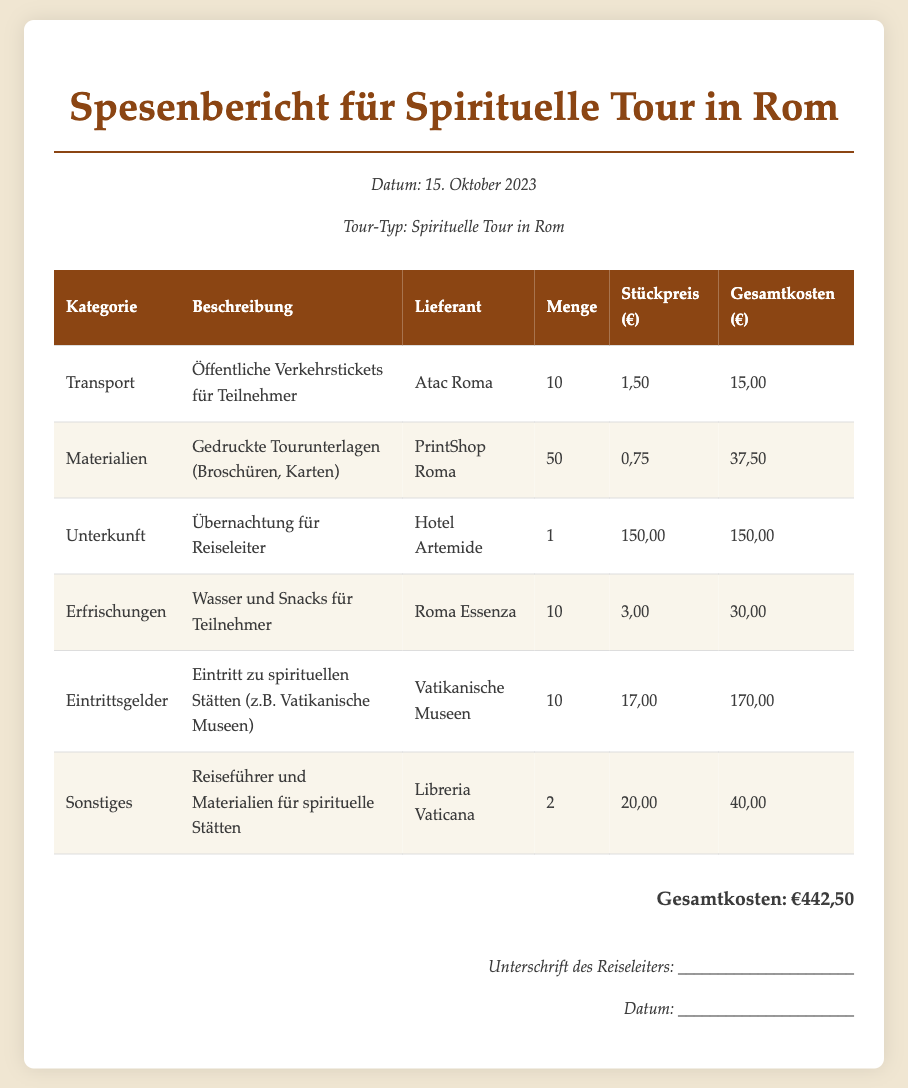Was ist das Datum des Spesenberichts? Das Datum des Spesenberichts ist im Bericht selbst ausgewiesen.
Answer: 15. Oktober 2023 Wie hoch sind die Gesamtkosten? Die Gesamtkosten sind am Ende des Berichts aufgeführt.
Answer: €442,50 Wer ist der Lieferant für die öffentlichen Verkehrstickets? Der Lieferant für die öffentlichen Verkehrstickets ist im jeweiligen Abschnitt angegeben.
Answer: Atac Roma Wie viele gedruckte Tourunterlagen wurden bestellt? Die Menge der gedruckten Tourunterlagen ist im entsprechenden Eintrag zu finden.
Answer: 50 Was kostet das Eintrittsgeld zu den spirituellen Stätten pro Person? Der Stückpreis für das Eintrittsgeld ist im Bericht angegeben.
Answer: 17,00 Was ist die Kategorie für die Wasserversorgung und Snacks? Die Kategorie wird im Bericht klar erwähnt und beschreibt den Kostenpunkt.
Answer: Erfrischungen Wie viel kostet die Übernachtung für den Reiseleiter? Die Artikelbeschreibung listet die Kosten für die Übernachtung auf.
Answer: 150,00 Welche Materialien wurden für die spirituellen Stätten gekauft? Die Materialien sind in der entsprechenden Zeile des Berichts aufgeführt.
Answer: Reiseführer und Materialien 